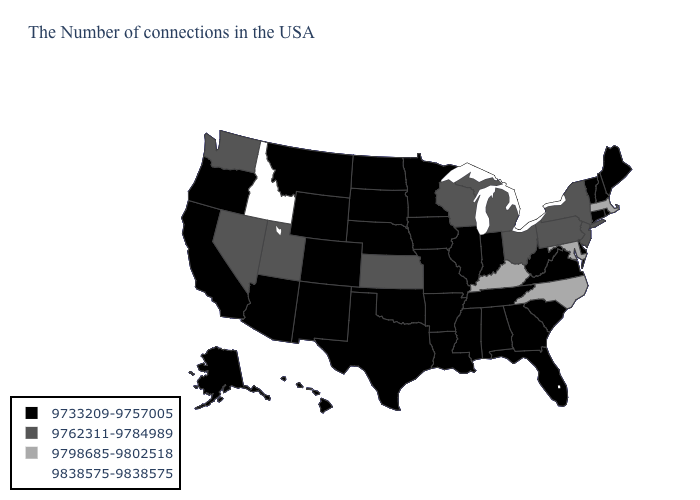Name the states that have a value in the range 9838575-9838575?
Concise answer only. Idaho. Name the states that have a value in the range 9762311-9784989?
Quick response, please. New York, New Jersey, Pennsylvania, Ohio, Michigan, Wisconsin, Kansas, Utah, Nevada, Washington. Does the map have missing data?
Answer briefly. No. Does Idaho have the highest value in the USA?
Short answer required. Yes. Among the states that border Missouri , does Arkansas have the highest value?
Keep it brief. No. What is the value of Idaho?
Answer briefly. 9838575-9838575. Among the states that border Arizona , which have the lowest value?
Be succinct. Colorado, New Mexico, California. Name the states that have a value in the range 9762311-9784989?
Be succinct. New York, New Jersey, Pennsylvania, Ohio, Michigan, Wisconsin, Kansas, Utah, Nevada, Washington. Name the states that have a value in the range 9762311-9784989?
Give a very brief answer. New York, New Jersey, Pennsylvania, Ohio, Michigan, Wisconsin, Kansas, Utah, Nevada, Washington. Name the states that have a value in the range 9762311-9784989?
Quick response, please. New York, New Jersey, Pennsylvania, Ohio, Michigan, Wisconsin, Kansas, Utah, Nevada, Washington. Name the states that have a value in the range 9733209-9757005?
Short answer required. Maine, Rhode Island, New Hampshire, Vermont, Connecticut, Delaware, Virginia, South Carolina, West Virginia, Florida, Georgia, Indiana, Alabama, Tennessee, Illinois, Mississippi, Louisiana, Missouri, Arkansas, Minnesota, Iowa, Nebraska, Oklahoma, Texas, South Dakota, North Dakota, Wyoming, Colorado, New Mexico, Montana, Arizona, California, Oregon, Alaska, Hawaii. Among the states that border Washington , which have the highest value?
Quick response, please. Idaho. Which states have the lowest value in the Northeast?
Quick response, please. Maine, Rhode Island, New Hampshire, Vermont, Connecticut. Which states have the highest value in the USA?
Be succinct. Idaho. Among the states that border Tennessee , which have the highest value?
Concise answer only. North Carolina, Kentucky. 